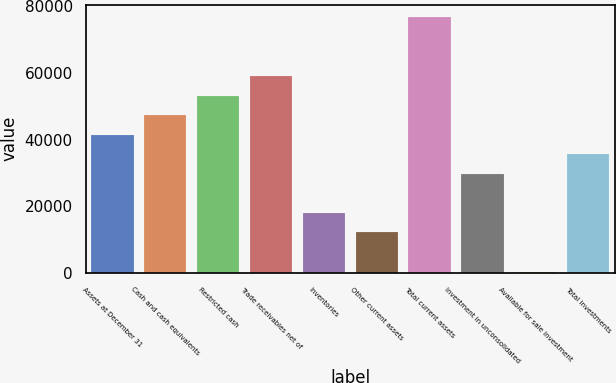<chart> <loc_0><loc_0><loc_500><loc_500><bar_chart><fcel>Assets at December 31<fcel>Cash and cash equivalents<fcel>Restricted cash<fcel>Trade receivables net of<fcel>Inventories<fcel>Other current assets<fcel>Total current assets<fcel>Investment in unconsolidated<fcel>Available for sale investment<fcel>Total investments<nl><fcel>41460.9<fcel>47327.6<fcel>53194.3<fcel>59061<fcel>17994.1<fcel>12127.4<fcel>76661.1<fcel>29727.5<fcel>394<fcel>35594.2<nl></chart> 